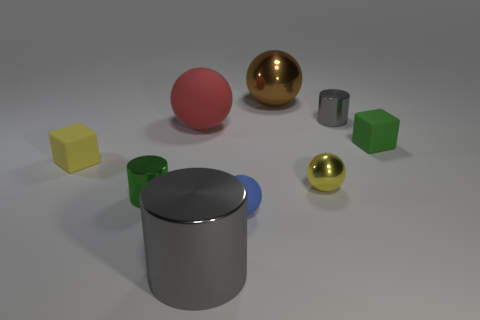Subtract all cylinders. How many objects are left? 6 Subtract all small blocks. Subtract all tiny purple shiny blocks. How many objects are left? 7 Add 2 small blue balls. How many small blue balls are left? 3 Add 6 large rubber spheres. How many large rubber spheres exist? 7 Subtract 1 green cylinders. How many objects are left? 8 